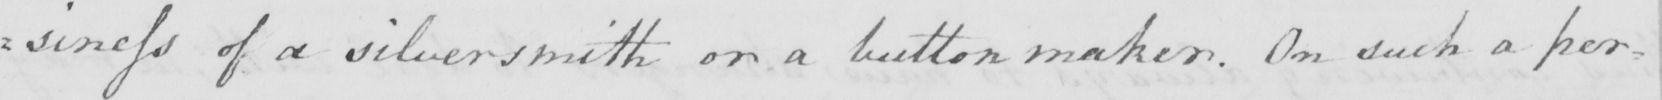Please transcribe the handwritten text in this image. : siness of a silversmith or a button maker . On such a per= 